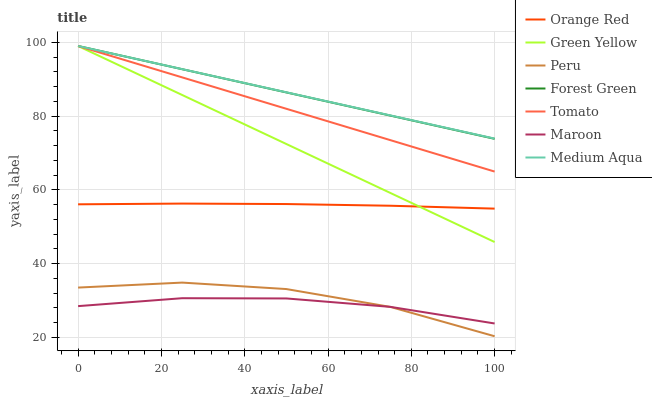Does Maroon have the minimum area under the curve?
Answer yes or no. Yes. Does Medium Aqua have the maximum area under the curve?
Answer yes or no. Yes. Does Forest Green have the minimum area under the curve?
Answer yes or no. No. Does Forest Green have the maximum area under the curve?
Answer yes or no. No. Is Tomato the smoothest?
Answer yes or no. Yes. Is Peru the roughest?
Answer yes or no. Yes. Is Maroon the smoothest?
Answer yes or no. No. Is Maroon the roughest?
Answer yes or no. No. Does Peru have the lowest value?
Answer yes or no. Yes. Does Maroon have the lowest value?
Answer yes or no. No. Does Green Yellow have the highest value?
Answer yes or no. Yes. Does Maroon have the highest value?
Answer yes or no. No. Is Maroon less than Orange Red?
Answer yes or no. Yes. Is Forest Green greater than Peru?
Answer yes or no. Yes. Does Tomato intersect Medium Aqua?
Answer yes or no. Yes. Is Tomato less than Medium Aqua?
Answer yes or no. No. Is Tomato greater than Medium Aqua?
Answer yes or no. No. Does Maroon intersect Orange Red?
Answer yes or no. No. 